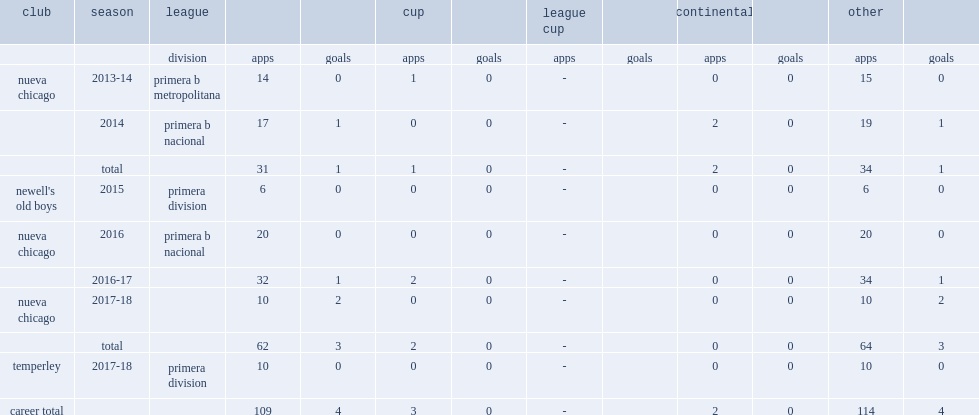Which club did fattori play for in 2015? Newell's old boys. 